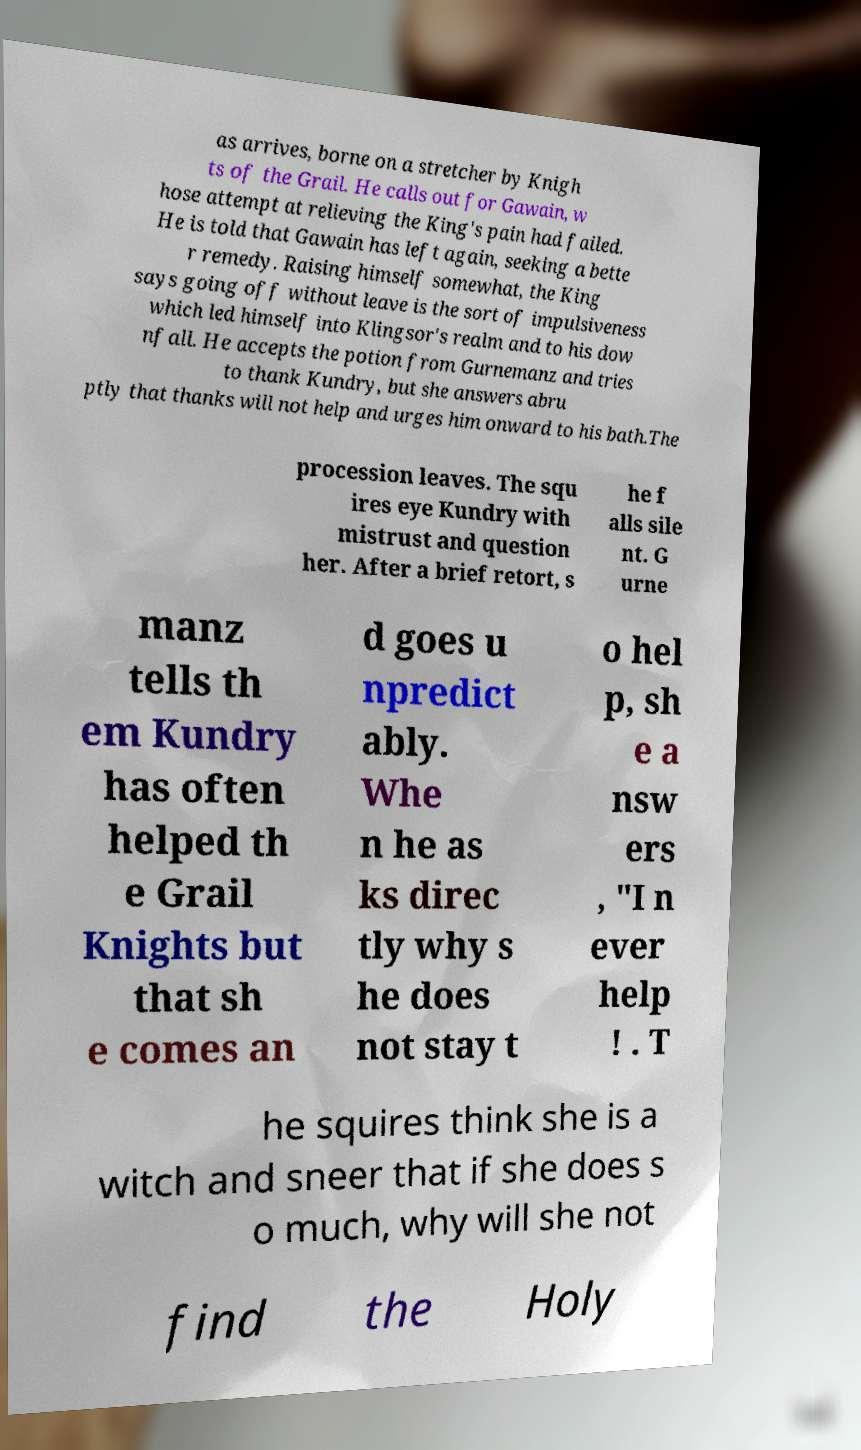Please identify and transcribe the text found in this image. as arrives, borne on a stretcher by Knigh ts of the Grail. He calls out for Gawain, w hose attempt at relieving the King's pain had failed. He is told that Gawain has left again, seeking a bette r remedy. Raising himself somewhat, the King says going off without leave is the sort of impulsiveness which led himself into Klingsor's realm and to his dow nfall. He accepts the potion from Gurnemanz and tries to thank Kundry, but she answers abru ptly that thanks will not help and urges him onward to his bath.The procession leaves. The squ ires eye Kundry with mistrust and question her. After a brief retort, s he f alls sile nt. G urne manz tells th em Kundry has often helped th e Grail Knights but that sh e comes an d goes u npredict ably. Whe n he as ks direc tly why s he does not stay t o hel p, sh e a nsw ers , "I n ever help ! . T he squires think she is a witch and sneer that if she does s o much, why will she not find the Holy 